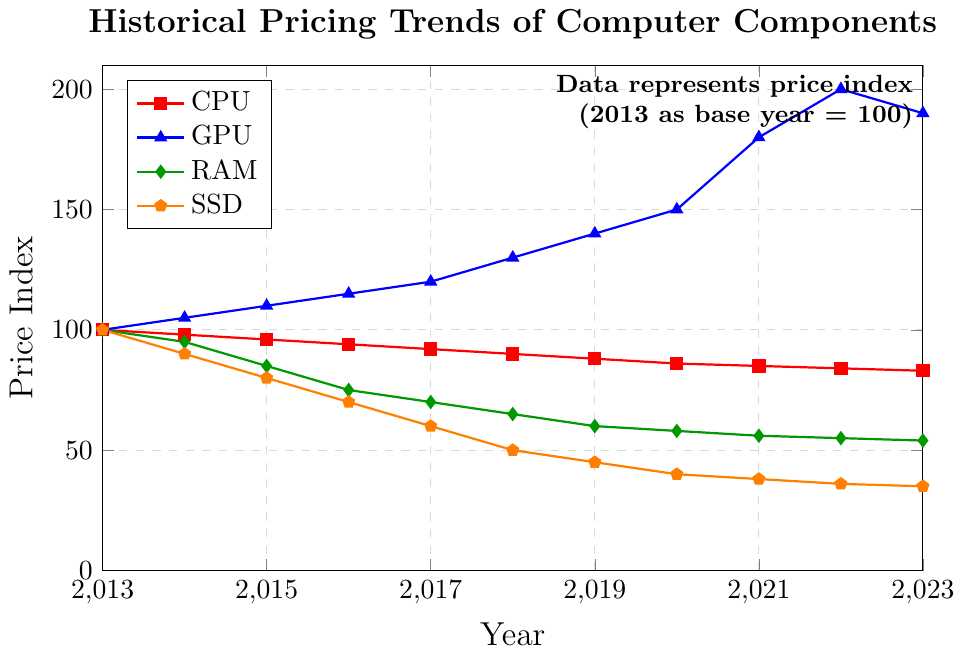Which component had the highest price index in 2023? Look for the year 2023 on the x-axis and identify which line is at the highest point. The GPU line is at the highest point, indicating that GPUs had the highest price index in 2023.
Answer: GPU Between 2015 and 2020, by how much did the price index for RAM decrease? Identify the price index for RAM in 2015 and 2020. Subtract the 2020 value from the 2015 value. The values are 85 (2015) and 58 (2020), so the decrease is 85 - 58 = 27.
Answer: 27 In which year did the price index for GPUs peak, and what was the value? Look for the highest point on the GPU line and note the corresponding year and price index. The highest point is in 2022 with a value of 200.
Answer: 2022, 200 Compare the price index trends for CPUs and SSDs over the decade. Which component had a more consistent decrease? Observe the slopes of the CPU and SSD lines from 2013 to 2023. The CPU line shows a steady and slight decline, while the SSD line shows a sharper decrease. Hence, CPUs had a more consistent decrease.
Answer: CPU What was the price index of SSDs in 2018, and how does it compare to the 2023 value? Locate the points for SSDs in 2018 and 2023, and note their values. The values are 50 (2018) and 35 (2023). Compare the two values: 50 - 35 = 15. SSDs saw a decrease of 15 points from 2018 to 2023.
Answer: 50, decreased by 15 What is the average price index for RAM over the given period? Sum the RAM prices for all years and divide by the number of years. The values are 100, 95, 85, 75, 70, 65, 60, 58, 56, 55, 54. Sum these (100 + 95 + 85 + 75 + 70 + 65 + 60 + 58 + 56 + 55 + 54) = 773. There are 11 years, so the average is 773 / 11 ≈ 70.27.
Answer: 70.27 By how much did the GPU price index change between 2021 and 2023? Identify the GPU price index values for 2021 and 2023. Subtract the 2023 value from the 2021 value. The values are 180 (2021) and 190 (2023). The change is 190 - 180 = 10.
Answer: 10 Which component experienced the most dramatic increase between any two consecutive years? Identify the steepest slope among all lines. The steepest increase is in the GPU line between 2020 and 2021, where the price index goes from 150 to 180. The change is 180 - 150 = 30.
Answer: GPU between 2020 and 2021 